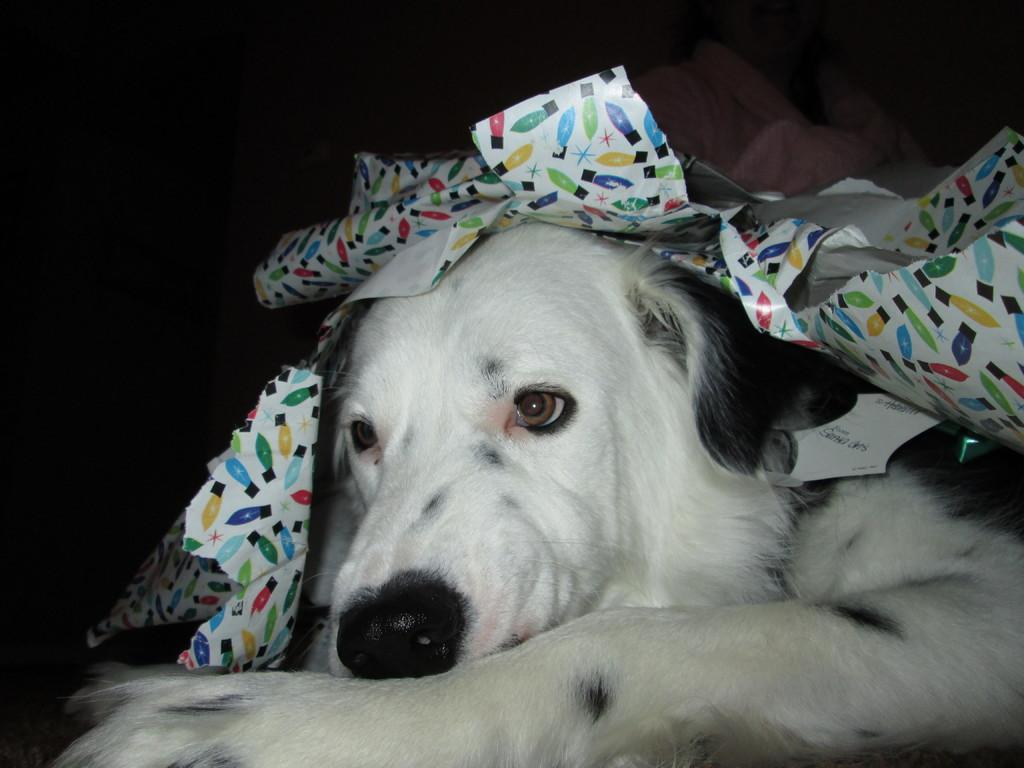What type of animal is in the image? There is a white dog in the image. What is the dog doing in the image? The dog is laying down. What is located above the dog in the image? There is a gift wrapper above the dog. How does the dog start a rainstorm in the image? The dog does not start a rainstorm in the image; there is no rainstorm depicted. 